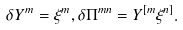<formula> <loc_0><loc_0><loc_500><loc_500>\delta Y ^ { m } = \xi ^ { m } , \delta \Pi ^ { m n } = Y ^ { [ m } \xi ^ { n ] } .</formula> 